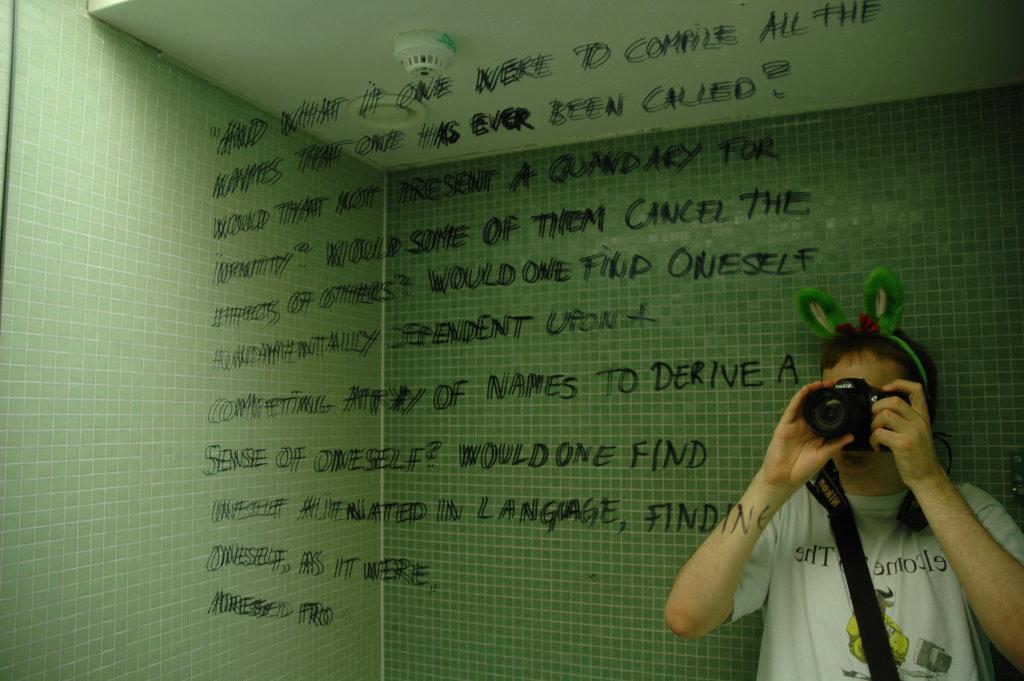Can you describe this image briefly? In this image there is a person holding a camera, there is the text written on the wall, there is a white roof. 